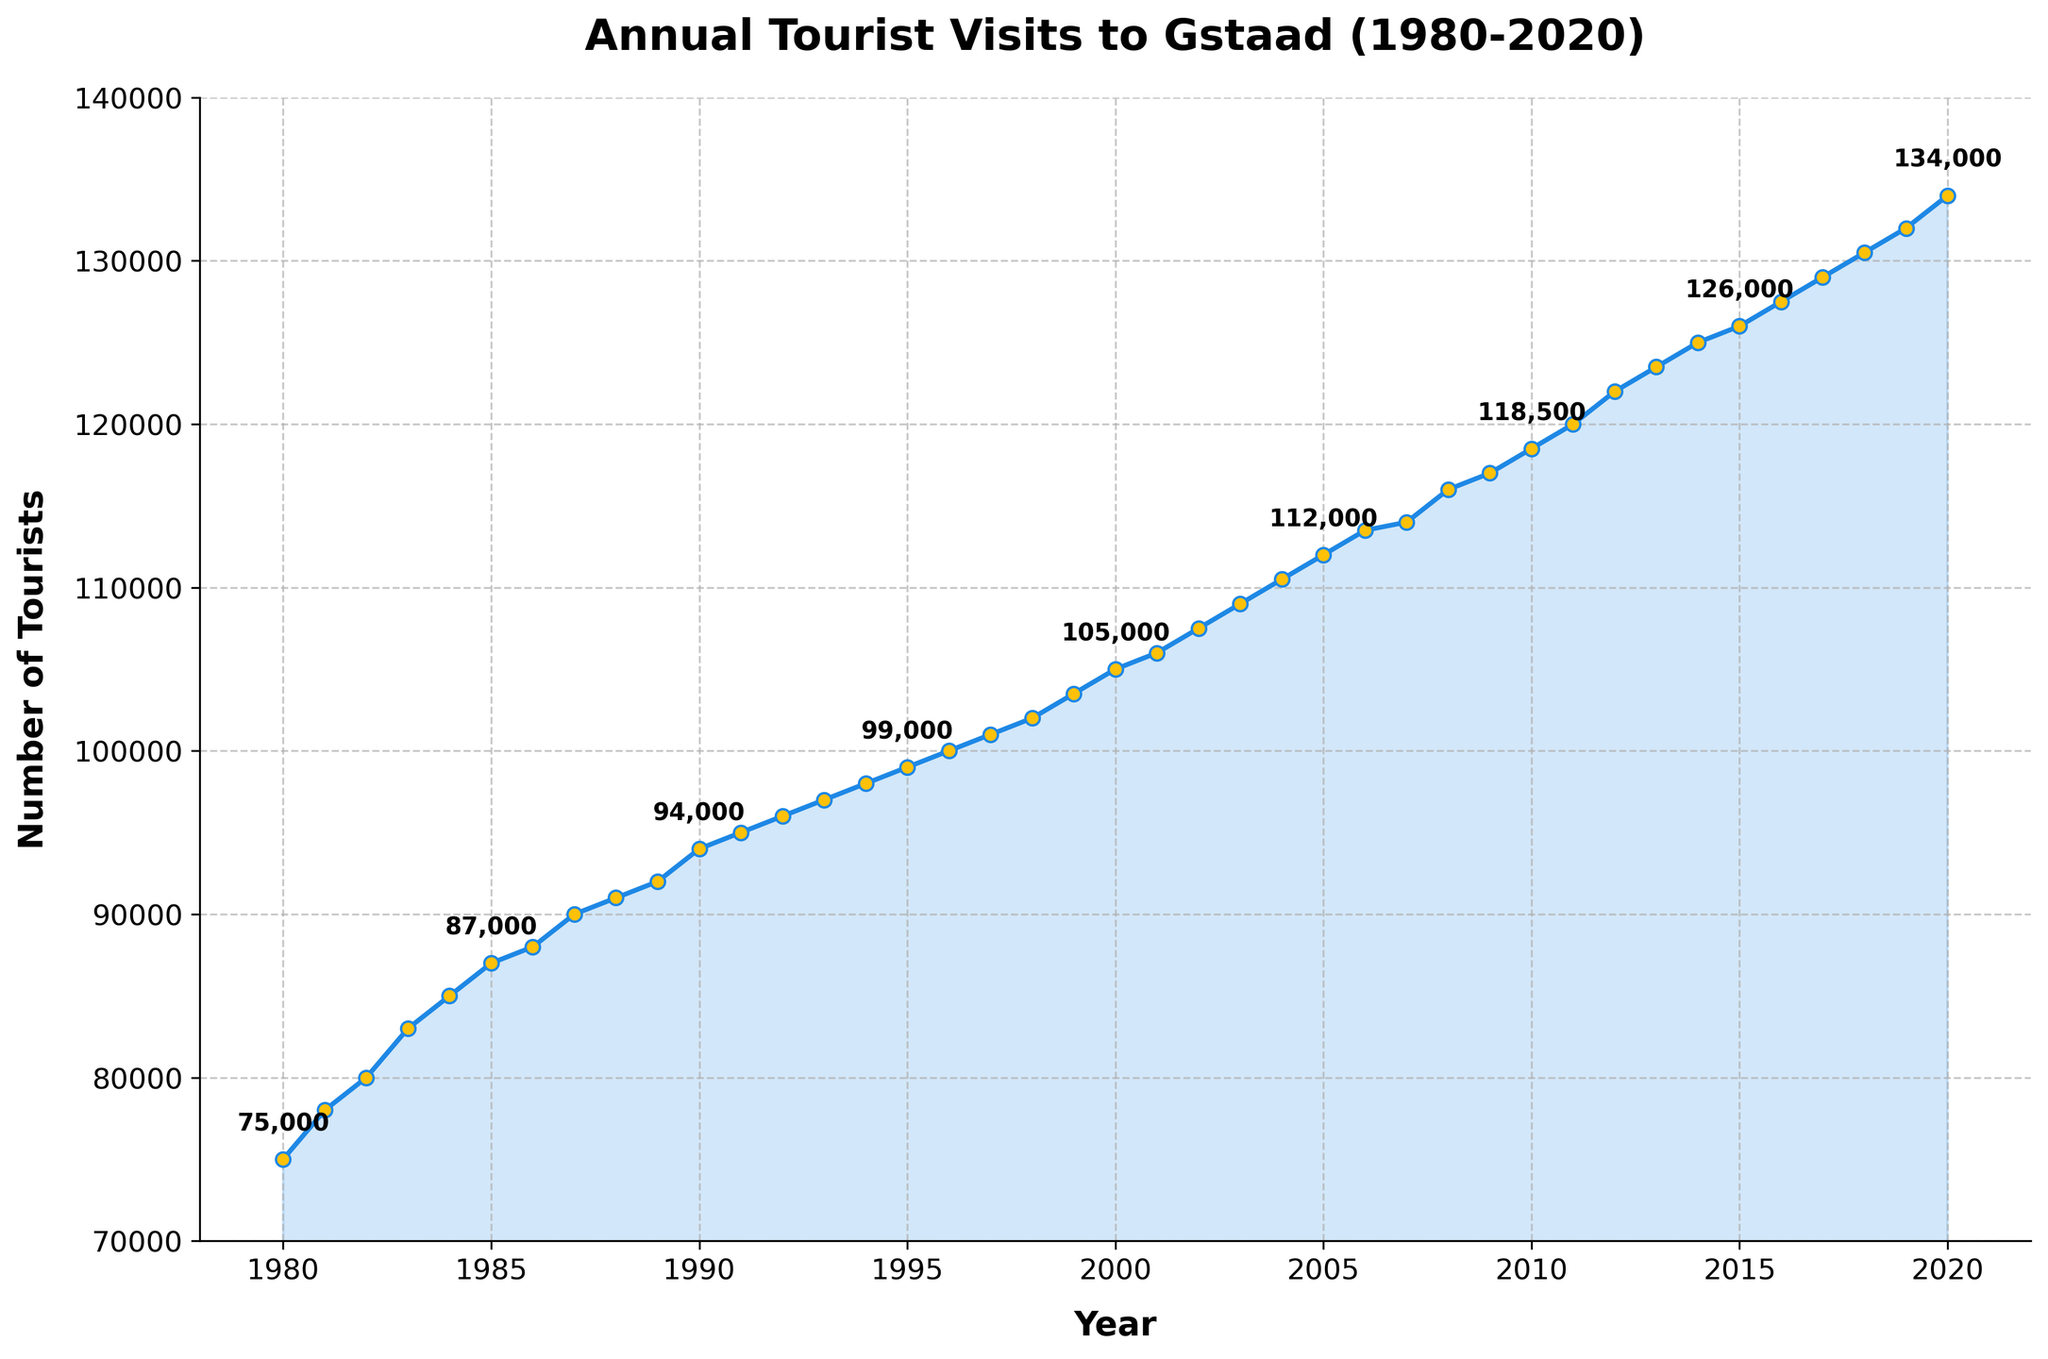What is the title of the figure? The title of the figure is written at the top center. It reads 'Annual Tourist Visits to Gstaad (1980-2020)'.
Answer: Annual Tourist Visits to Gstaad (1980-2020) What are the units of the y-axis? The y-axis units are specified by the label next to the axis. It reads 'Number of Tourists'.
Answer: Number of Tourists How many tourists visited Gstaad in 1980? To find the number of tourists in 1980, look at the point corresponding to 1980 on the x-axis and check its y-axis value. The y-axis value for 1980 is 75,000.
Answer: 75,000 In which year did the number of tourists first reach 100,000? To find this information, identify the point where the y-axis value first equals or exceeds 100,000. This happens in the year 1996.
Answer: 1996 Which year saw a higher number of tourists, 2000 or 2010? Compare the y-axis values for the years 2000 and 2010. In 2000, the number is 105,000, and in 2010, it is 118,500. Since 118,500 > 105,000, 2010 saw more tourists.
Answer: 2010 What is the approximate average annual increase in tourists from 1980 to 2020? To find the average annual increase, calculate the total increase in the number of tourists from 1980 to 2020 and then divide by the number of years. Increase = 134,000 - 75,000 = 59,000. Number of years = 2020 - 1980 = 40. Average annual increase = 59,000 / 40 = 1,475.
Answer: About 1,475 Was there ever a period of decline in the number of tourists? To determine this, look for any points on the plot where the number of tourists in a year is less than in the previous year. There are no such points in the plot, indicating no year-over-year decline.
Answer: No By how much did the number of tourists increase from 1990 to 2000? Calculate the difference in the number of tourists between these two years. Number of tourists in 1990 was 94,000, and in 2000 it was 105,000. So, the increase is 105,000 - 94,000 = 11,000.
Answer: 11,000 Which year marks the steepest increase in the number of tourists within a five-year interval? Examine the plot and calculate the differences in the number of tourists over each five-year span. The steepest five-year increase occurs between 2015 and 2020 with an increase from 126,000 to 134,000. Increase = 134,000 - 126,000 = 8,000.
Answer: 2015 to 2020 